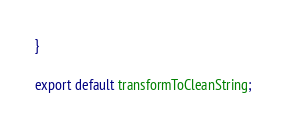<code> <loc_0><loc_0><loc_500><loc_500><_JavaScript_>}

export default transformToCleanString;
</code> 